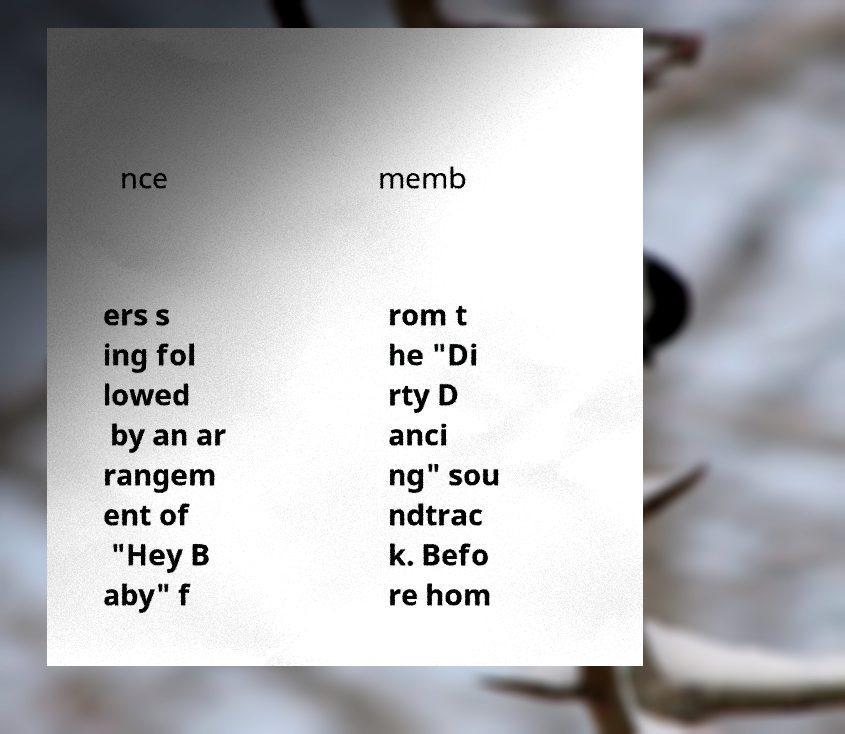Can you read and provide the text displayed in the image?This photo seems to have some interesting text. Can you extract and type it out for me? nce memb ers s ing fol lowed by an ar rangem ent of "Hey B aby" f rom t he "Di rty D anci ng" sou ndtrac k. Befo re hom 